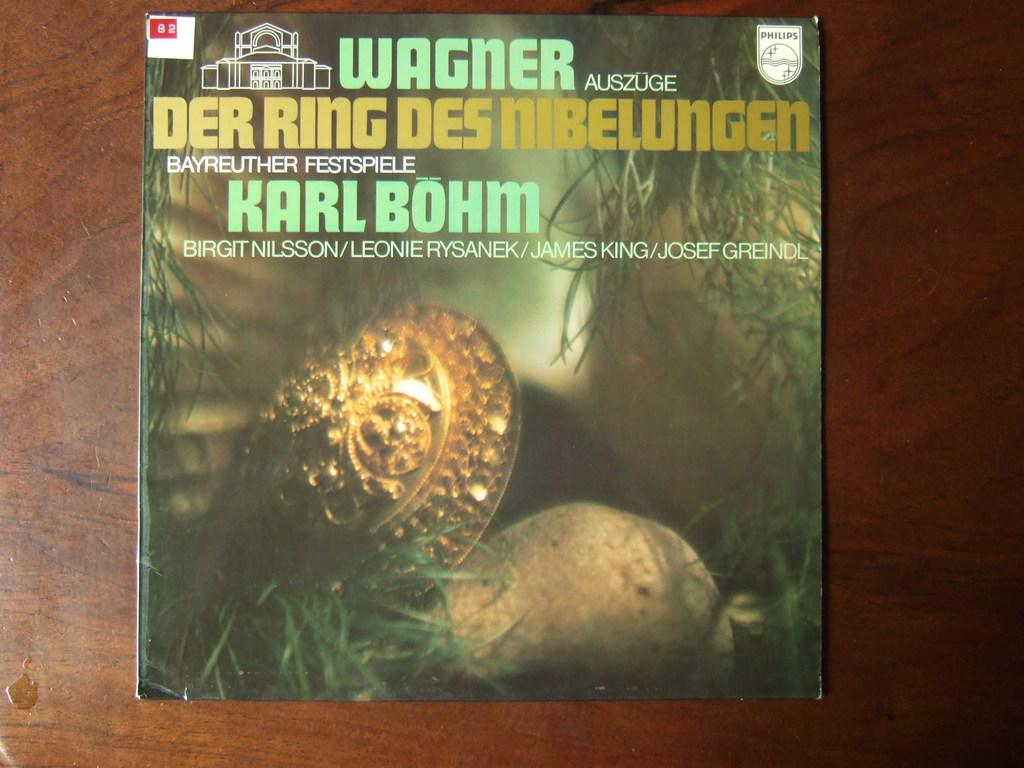Provide a one-sentence caption for the provided image. A book on a table has a red printed label with the number 82. 